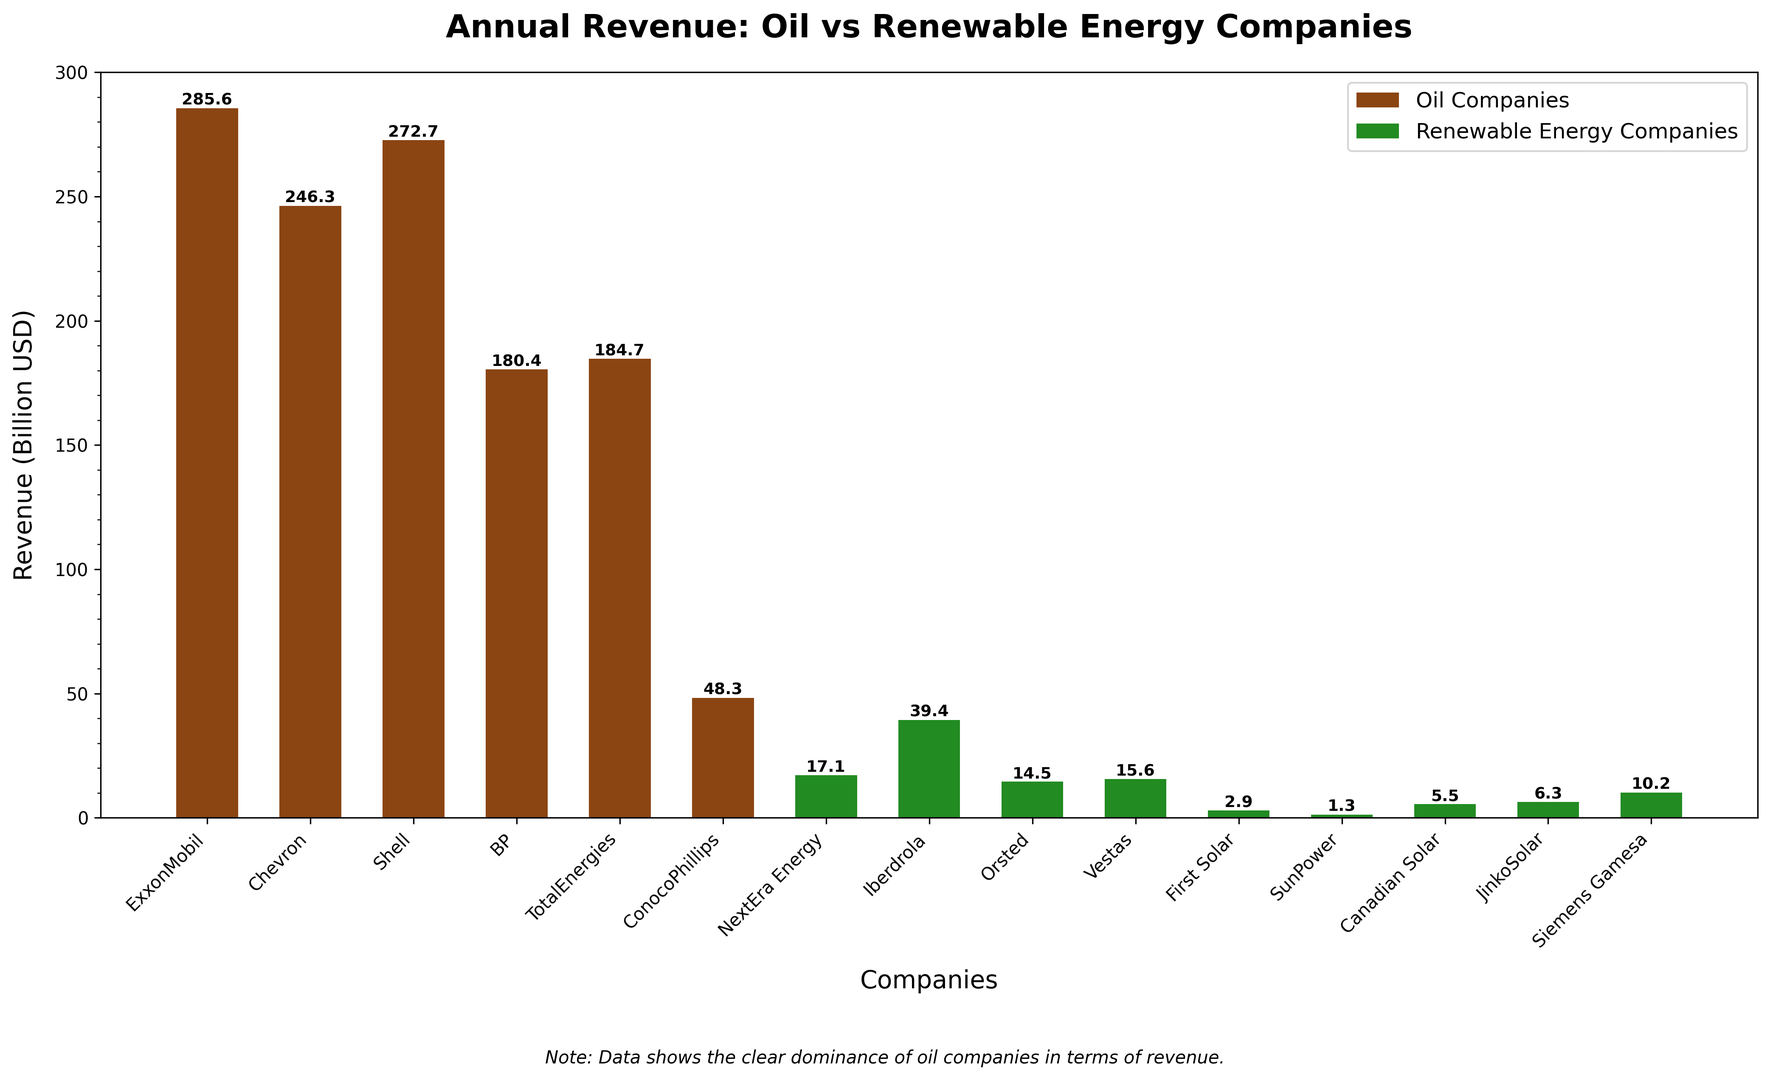Which company has the highest revenue? By looking at the longest bar in the chart, we can identify the company with the highest revenue. The company with the highest revenue is ExxonMobil, as represented by the tallest bar.
Answer: ExxonMobil Which company among renewable energy companies has the highest revenue? We need to look into the green bars specifically representing the renewable energy companies. The tallest green bar represents Iberdrola which has the highest revenue among renewable energy companies.
Answer: Iberdrola What is the combined revenue of Shell and BP? To find the combined revenue, we sum the revenues of Shell and BP. Shell has a revenue of 272.7 billion USD, and BP has a revenue of 180.4 billion USD. Therefore, the combined revenue is 272.7 + 180.4 = 453.1 billion USD.
Answer: 453.1 billion USD How does the revenue of NextEra Energy compare to the revenue of ConocoPhillips? We compare the height of the bars representing NextEra Energy and ConocoPhillips. ConocoPhillips has a revenue of 48.3 billion USD, while NextEra Energy has a revenue of 17.1 billion USD, making ConocoPhillips' revenue significantly higher.
Answer: ConocoPhillips has higher revenue Which has a higher total revenue: oil companies or renewable energy companies? First, sum the revenues of the oil companies and renewable energy companies separately. Oil companies have revenues: 285.6 + 246.3 + 272.7 + 180.4 + 184.7 + 48.3 = 1218 billion USD. Renewable energy companies have revenues: 17.1 + 39.4 + 14.5 + 15.6 + 2.9 + 1.3 + 5.5 + 6.3 + 10.2 = 112.8 billion USD. Therefore, oil companies have a higher total revenue.
Answer: Oil companies By how much does Chevron's revenue exceed the combined revenue of SunPower and First Solar? Chevron's revenue is 246.3 billion USD. The combined revenue of SunPower and First Solar is 1.3 + 2.9 = 4.2 billion USD. Thus, Chevron's revenue exceeds this combined revenue by 246.3 - 4.2 = 242.1 billion USD.
Answer: 242.1 billion USD What is the average revenue of the oil companies? To calculate the average, sum the revenues of the oil companies and divide by the number of oil companies. The total revenue of the oil companies is 1218 billion USD, and there are 6 oil companies. Therefore, the average revenue is 1218 / 6 = 203 billion USD.
Answer: 203 billion USD Which renewable energy company has the lowest revenue? We need to examine the green bars representing renewable energy companies and identify the shortest bar. The shortest bar represents SunPower, indicating that it has the lowest revenue among renewable energy companies.
Answer: SunPower How much more revenue does ExxonMobil generate compared to JinkoSolar? ExxonMobil has a revenue of 285.6 billion USD, and JinkoSolar has a revenue of 6.3 billion USD. The difference in revenue would be 285.6 - 6.3 = 279.3 billion USD.
Answer: 279.3 billion USD 